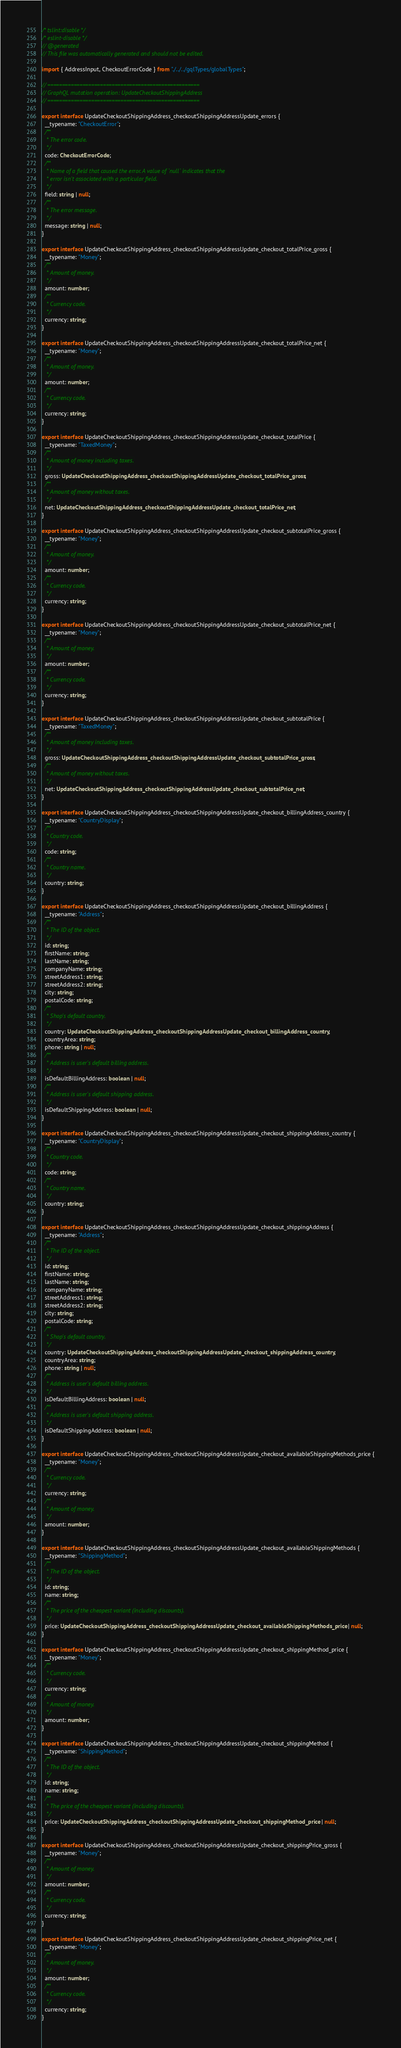<code> <loc_0><loc_0><loc_500><loc_500><_TypeScript_>/* tslint:disable */
/* eslint-disable */
// @generated
// This file was automatically generated and should not be edited.

import { AddressInput, CheckoutErrorCode } from "./../../gqlTypes/globalTypes";

// ====================================================
// GraphQL mutation operation: UpdateCheckoutShippingAddress
// ====================================================

export interface UpdateCheckoutShippingAddress_checkoutShippingAddressUpdate_errors {
  __typename: "CheckoutError";
  /**
   * The error code.
   */
  code: CheckoutErrorCode;
  /**
   * Name of a field that caused the error. A value of `null` indicates that the
   * error isn't associated with a particular field.
   */
  field: string | null;
  /**
   * The error message.
   */
  message: string | null;
}

export interface UpdateCheckoutShippingAddress_checkoutShippingAddressUpdate_checkout_totalPrice_gross {
  __typename: "Money";
  /**
   * Amount of money.
   */
  amount: number;
  /**
   * Currency code.
   */
  currency: string;
}

export interface UpdateCheckoutShippingAddress_checkoutShippingAddressUpdate_checkout_totalPrice_net {
  __typename: "Money";
  /**
   * Amount of money.
   */
  amount: number;
  /**
   * Currency code.
   */
  currency: string;
}

export interface UpdateCheckoutShippingAddress_checkoutShippingAddressUpdate_checkout_totalPrice {
  __typename: "TaxedMoney";
  /**
   * Amount of money including taxes.
   */
  gross: UpdateCheckoutShippingAddress_checkoutShippingAddressUpdate_checkout_totalPrice_gross;
  /**
   * Amount of money without taxes.
   */
  net: UpdateCheckoutShippingAddress_checkoutShippingAddressUpdate_checkout_totalPrice_net;
}

export interface UpdateCheckoutShippingAddress_checkoutShippingAddressUpdate_checkout_subtotalPrice_gross {
  __typename: "Money";
  /**
   * Amount of money.
   */
  amount: number;
  /**
   * Currency code.
   */
  currency: string;
}

export interface UpdateCheckoutShippingAddress_checkoutShippingAddressUpdate_checkout_subtotalPrice_net {
  __typename: "Money";
  /**
   * Amount of money.
   */
  amount: number;
  /**
   * Currency code.
   */
  currency: string;
}

export interface UpdateCheckoutShippingAddress_checkoutShippingAddressUpdate_checkout_subtotalPrice {
  __typename: "TaxedMoney";
  /**
   * Amount of money including taxes.
   */
  gross: UpdateCheckoutShippingAddress_checkoutShippingAddressUpdate_checkout_subtotalPrice_gross;
  /**
   * Amount of money without taxes.
   */
  net: UpdateCheckoutShippingAddress_checkoutShippingAddressUpdate_checkout_subtotalPrice_net;
}

export interface UpdateCheckoutShippingAddress_checkoutShippingAddressUpdate_checkout_billingAddress_country {
  __typename: "CountryDisplay";
  /**
   * Country code.
   */
  code: string;
  /**
   * Country name.
   */
  country: string;
}

export interface UpdateCheckoutShippingAddress_checkoutShippingAddressUpdate_checkout_billingAddress {
  __typename: "Address";
  /**
   * The ID of the object.
   */
  id: string;
  firstName: string;
  lastName: string;
  companyName: string;
  streetAddress1: string;
  streetAddress2: string;
  city: string;
  postalCode: string;
  /**
   * Shop's default country.
   */
  country: UpdateCheckoutShippingAddress_checkoutShippingAddressUpdate_checkout_billingAddress_country;
  countryArea: string;
  phone: string | null;
  /**
   * Address is user's default billing address.
   */
  isDefaultBillingAddress: boolean | null;
  /**
   * Address is user's default shipping address.
   */
  isDefaultShippingAddress: boolean | null;
}

export interface UpdateCheckoutShippingAddress_checkoutShippingAddressUpdate_checkout_shippingAddress_country {
  __typename: "CountryDisplay";
  /**
   * Country code.
   */
  code: string;
  /**
   * Country name.
   */
  country: string;
}

export interface UpdateCheckoutShippingAddress_checkoutShippingAddressUpdate_checkout_shippingAddress {
  __typename: "Address";
  /**
   * The ID of the object.
   */
  id: string;
  firstName: string;
  lastName: string;
  companyName: string;
  streetAddress1: string;
  streetAddress2: string;
  city: string;
  postalCode: string;
  /**
   * Shop's default country.
   */
  country: UpdateCheckoutShippingAddress_checkoutShippingAddressUpdate_checkout_shippingAddress_country;
  countryArea: string;
  phone: string | null;
  /**
   * Address is user's default billing address.
   */
  isDefaultBillingAddress: boolean | null;
  /**
   * Address is user's default shipping address.
   */
  isDefaultShippingAddress: boolean | null;
}

export interface UpdateCheckoutShippingAddress_checkoutShippingAddressUpdate_checkout_availableShippingMethods_price {
  __typename: "Money";
  /**
   * Currency code.
   */
  currency: string;
  /**
   * Amount of money.
   */
  amount: number;
}

export interface UpdateCheckoutShippingAddress_checkoutShippingAddressUpdate_checkout_availableShippingMethods {
  __typename: "ShippingMethod";
  /**
   * The ID of the object.
   */
  id: string;
  name: string;
  /**
   * The price of the cheapest variant (including discounts).
   */
  price: UpdateCheckoutShippingAddress_checkoutShippingAddressUpdate_checkout_availableShippingMethods_price | null;
}

export interface UpdateCheckoutShippingAddress_checkoutShippingAddressUpdate_checkout_shippingMethod_price {
  __typename: "Money";
  /**
   * Currency code.
   */
  currency: string;
  /**
   * Amount of money.
   */
  amount: number;
}

export interface UpdateCheckoutShippingAddress_checkoutShippingAddressUpdate_checkout_shippingMethod {
  __typename: "ShippingMethod";
  /**
   * The ID of the object.
   */
  id: string;
  name: string;
  /**
   * The price of the cheapest variant (including discounts).
   */
  price: UpdateCheckoutShippingAddress_checkoutShippingAddressUpdate_checkout_shippingMethod_price | null;
}

export interface UpdateCheckoutShippingAddress_checkoutShippingAddressUpdate_checkout_shippingPrice_gross {
  __typename: "Money";
  /**
   * Amount of money.
   */
  amount: number;
  /**
   * Currency code.
   */
  currency: string;
}

export interface UpdateCheckoutShippingAddress_checkoutShippingAddressUpdate_checkout_shippingPrice_net {
  __typename: "Money";
  /**
   * Amount of money.
   */
  amount: number;
  /**
   * Currency code.
   */
  currency: string;
}
</code> 